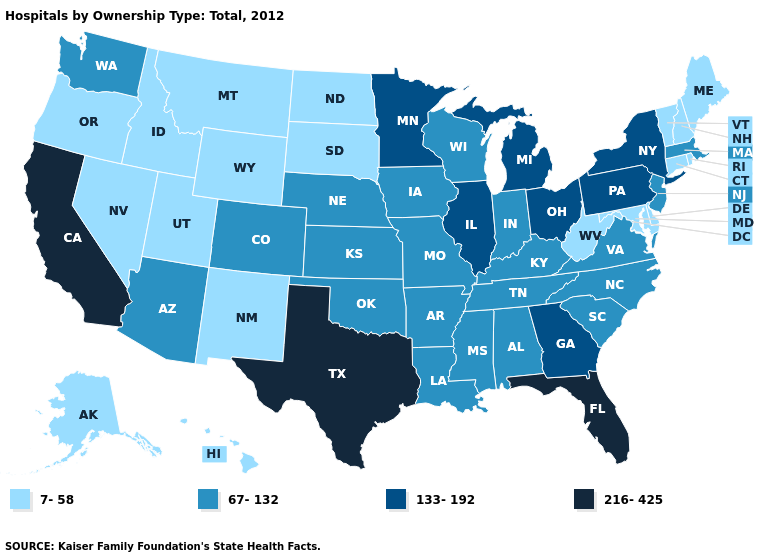Does Hawaii have the lowest value in the USA?
Keep it brief. Yes. Name the states that have a value in the range 216-425?
Quick response, please. California, Florida, Texas. What is the value of Maine?
Concise answer only. 7-58. Which states have the highest value in the USA?
Write a very short answer. California, Florida, Texas. Does New Mexico have the lowest value in the USA?
Write a very short answer. Yes. Name the states that have a value in the range 133-192?
Answer briefly. Georgia, Illinois, Michigan, Minnesota, New York, Ohio, Pennsylvania. What is the value of Alabama?
Answer briefly. 67-132. Does Vermont have the lowest value in the USA?
Give a very brief answer. Yes. What is the value of Michigan?
Short answer required. 133-192. Which states hav the highest value in the West?
Concise answer only. California. Does Iowa have the same value as Washington?
Keep it brief. Yes. What is the value of South Dakota?
Answer briefly. 7-58. Does the map have missing data?
Give a very brief answer. No. What is the highest value in states that border Illinois?
Write a very short answer. 67-132. 